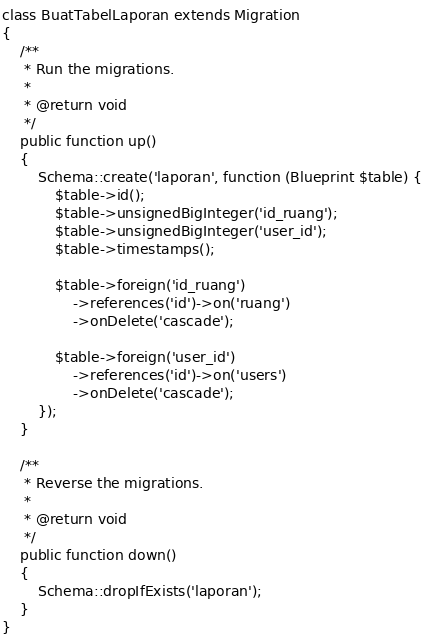<code> <loc_0><loc_0><loc_500><loc_500><_PHP_>class BuatTabelLaporan extends Migration
{
    /**
     * Run the migrations.
     *
     * @return void
     */
    public function up()
    {
        Schema::create('laporan', function (Blueprint $table) {
            $table->id();
            $table->unsignedBigInteger('id_ruang');
            $table->unsignedBigInteger('user_id');
            $table->timestamps();

            $table->foreign('id_ruang')
                ->references('id')->on('ruang')
                ->onDelete('cascade');

            $table->foreign('user_id')
                ->references('id')->on('users')
                ->onDelete('cascade');
        });
    }

    /**
     * Reverse the migrations.
     *
     * @return void
     */
    public function down()
    {
        Schema::dropIfExists('laporan');
    }
}
</code> 